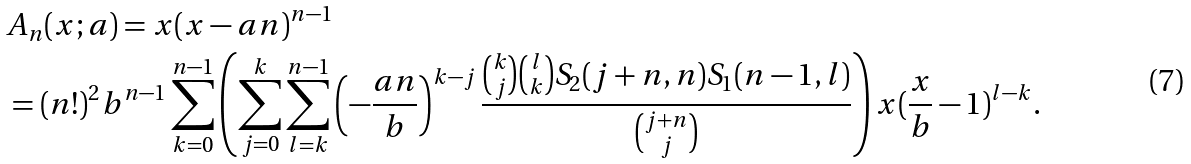Convert formula to latex. <formula><loc_0><loc_0><loc_500><loc_500>& A _ { n } ( x ; a ) = x ( x - a n ) ^ { n - 1 } \\ & = ( n ! ) ^ { 2 } b ^ { n - 1 } \sum _ { k = 0 } ^ { n - 1 } \left ( \sum _ { j = 0 } ^ { k } \sum _ { l = k } ^ { n - 1 } \left ( - \frac { a n } { b } \right ) ^ { k - j } \frac { \binom { k } { j } \binom { l } { k } S _ { 2 } ( j + n , n ) S _ { 1 } ( n - 1 , l ) } { \binom { j + n } { j } } \right ) x ( \frac { x } { b } - 1 ) ^ { l - k } .</formula> 